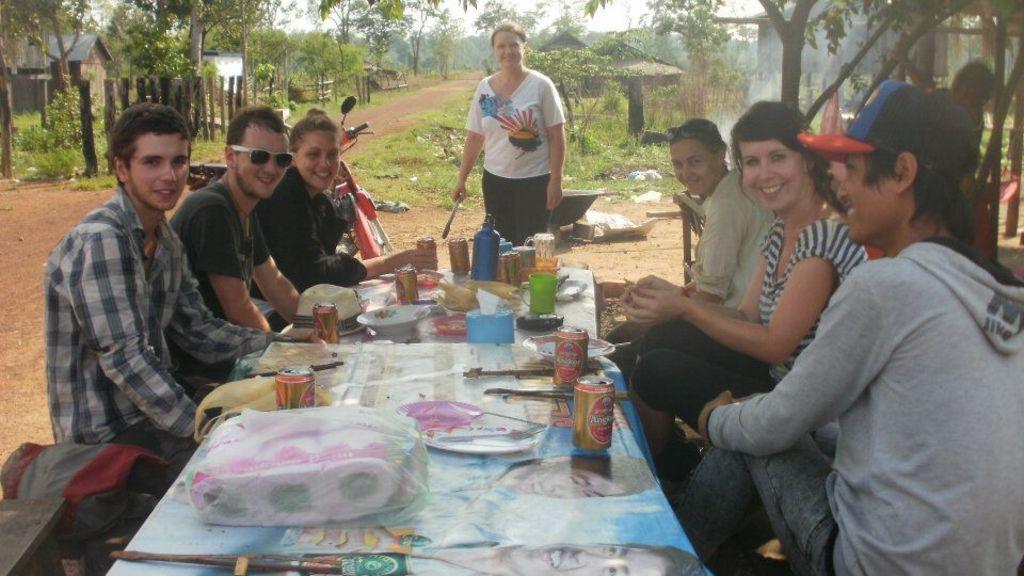Describe this image in one or two sentences. There are a six people who are sitting on a chair and having a food. Here we can see a woman standing in the center and she is smiling. In the background we can see a house and a trees. 